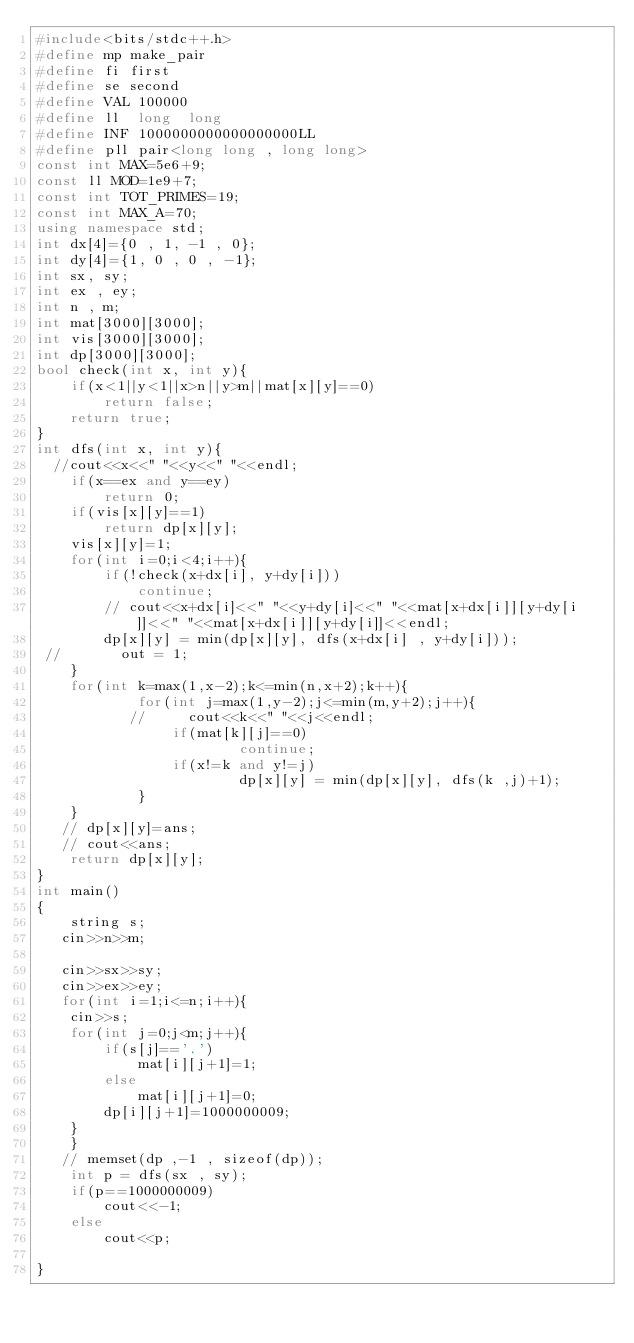<code> <loc_0><loc_0><loc_500><loc_500><_C++_>#include<bits/stdc++.h>
#define mp make_pair
#define fi first
#define se second
#define VAL 100000
#define ll  long  long
#define INF 1000000000000000000LL
#define pll pair<long long , long long>
const int MAX=5e6+9;
const ll MOD=1e9+7;
const int TOT_PRIMES=19;
const int MAX_A=70;
using namespace std;
int dx[4]={0 , 1, -1 , 0};
int dy[4]={1, 0 , 0 , -1};
int sx, sy;
int ex , ey;
int n , m;
int mat[3000][3000];
int vis[3000][3000];
int dp[3000][3000];
bool check(int x, int y){
    if(x<1||y<1||x>n||y>m||mat[x][y]==0)
        return false;
    return true;
}
int dfs(int x, int y){
  //cout<<x<<" "<<y<<" "<<endl;
    if(x==ex and y==ey)
        return 0;
    if(vis[x][y]==1)
        return dp[x][y];
    vis[x][y]=1;
    for(int i=0;i<4;i++){
        if(!check(x+dx[i], y+dy[i]))
            continue;
        // cout<<x+dx[i]<<" "<<y+dy[i]<<" "<<mat[x+dx[i]][y+dy[i]]<<" "<<mat[x+dx[i]][y+dy[i]]<<endl;
        dp[x][y] = min(dp[x][y], dfs(x+dx[i] , y+dy[i]));
 //       out = 1;
    }
    for(int k=max(1,x-2);k<=min(n,x+2);k++){
            for(int j=max(1,y-2);j<=min(m,y+2);j++){
           //     cout<<k<<" "<<j<<endl;
                if(mat[k][j]==0)
                        continue;
                if(x!=k and y!=j)
                        dp[x][y] = min(dp[x][y], dfs(k ,j)+1);
            }
    }
   // dp[x][y]=ans;
   // cout<<ans;
    return dp[x][y];    
}
int main() 
{
    string s;
   cin>>n>>m;
   
   cin>>sx>>sy;
   cin>>ex>>ey;
   for(int i=1;i<=n;i++){
    cin>>s;
    for(int j=0;j<m;j++){
        if(s[j]=='.')
            mat[i][j+1]=1;
        else
            mat[i][j+1]=0;
        dp[i][j+1]=1000000009;
    }
    }
   // memset(dp ,-1 , sizeof(dp));
    int p = dfs(sx , sy);
    if(p==1000000009)
        cout<<-1;
    else
        cout<<p;

}
</code> 